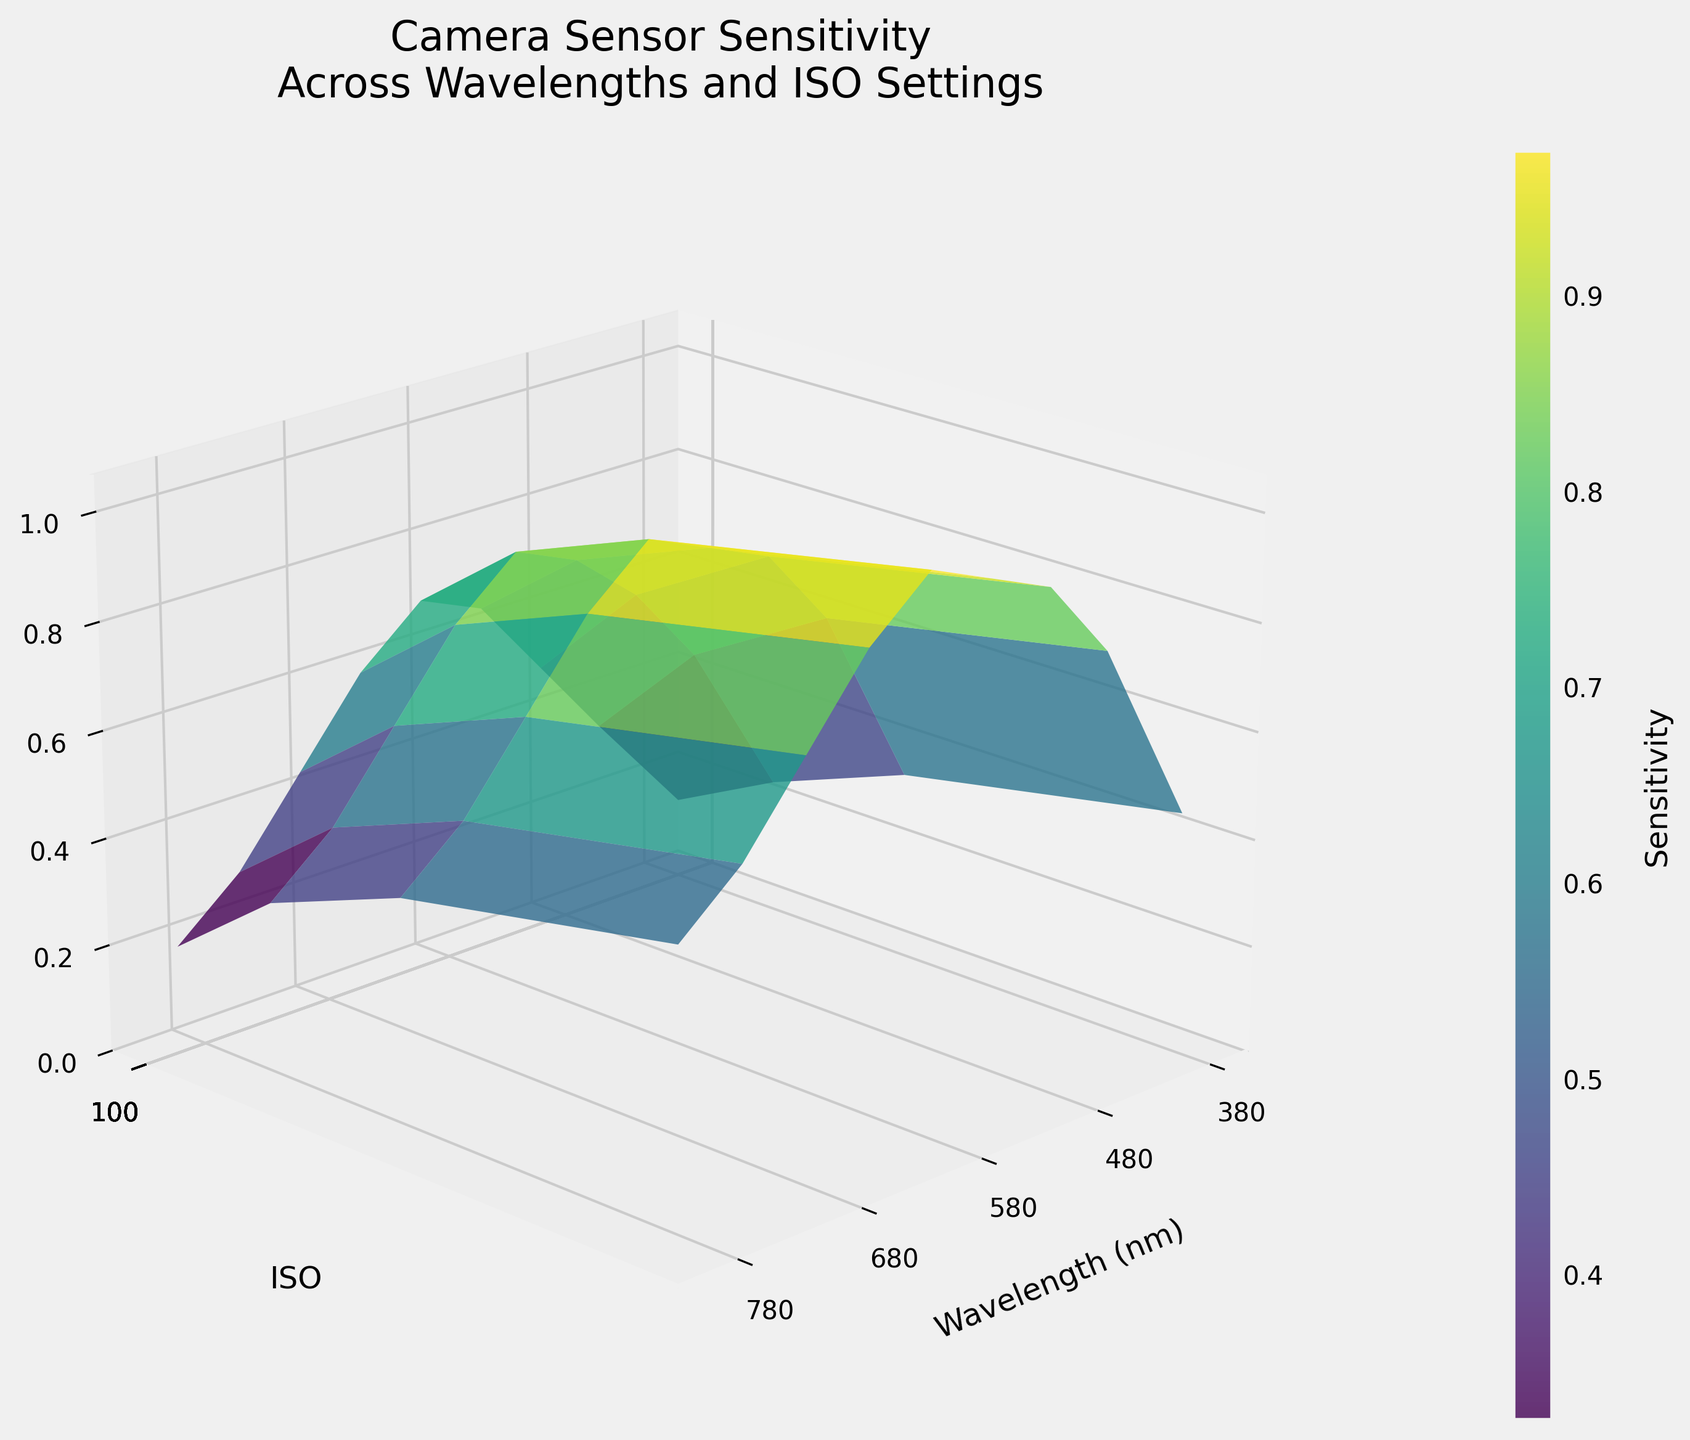What is the title of the 3D surface plot? The title can be found at the top of the figure. It summarizes the main subject of the plot.
Answer: Camera Sensor Sensitivity Across Wavelengths and ISO Settings Which axis represents the light wavelength? The light wavelength is represented on the x-axis, as indicated by the label "Wavelength (nm)".
Answer: x-axis What is the sensitivity at a wavelength of 550 nm and ISO 800? To find the sensitivity, locate the wavelength of 550 nm on the x-axis and ISO 800 on the y-axis, then find where they intersect on the z-axis.
Answer: 0.90 How does sensitivity change as ISO increases from 100 to 1600 at a wavelength of 450 nm? Track the changes at 450 nm across the ISO settings. Sensitivity increases from 0.35 at ISO 100 to 0.80 at ISO 1600.
Answer: Increases Is there a wavelength at which the sensitivity is the same across all ISO settings? Check if any wavelength value has the same sensitivity for ISO 100, 400, 800, and 1600. There is no such point in the given data.
Answer: No What is the general trend of sensitivity as the wavelength increases from 380 nm to 800 nm at ISO 100? Observe the plot line for ISO 100. The sensitivity initially increases, peaks between 550-600 nm, and then decreases.
Answer: Increases then decreases Compare the sensitivity at 600 nm for ISO 400 and ISO 1600. Find where 600 nm intersects with ISO 400 and ISO 1600 on the plot, and compare sensitivity values.
Answer: ISO 1600 has higher sensitivity Which ISO setting generally shows the highest sensitivity? Observe the plot and determine which ISO setting has the highest surface values. ISO 1600 generally shows the highest sensitivity.
Answer: ISO 1600 At which wavelength does ISO 100 reach its peak sensitivity? Track the plot for ISO 100 and locate the wavelength where the peak sensitivity occurs.
Answer: 600 nm What is the difference in sensitivity between ISO 400 and ISO 100 at a wavelength of 500 nm? Find the sensitivity values for ISO 400 and ISO 100 at 500 nm, then subtract the value of ISO 100 from ISO 400.
Answer: 0.20 